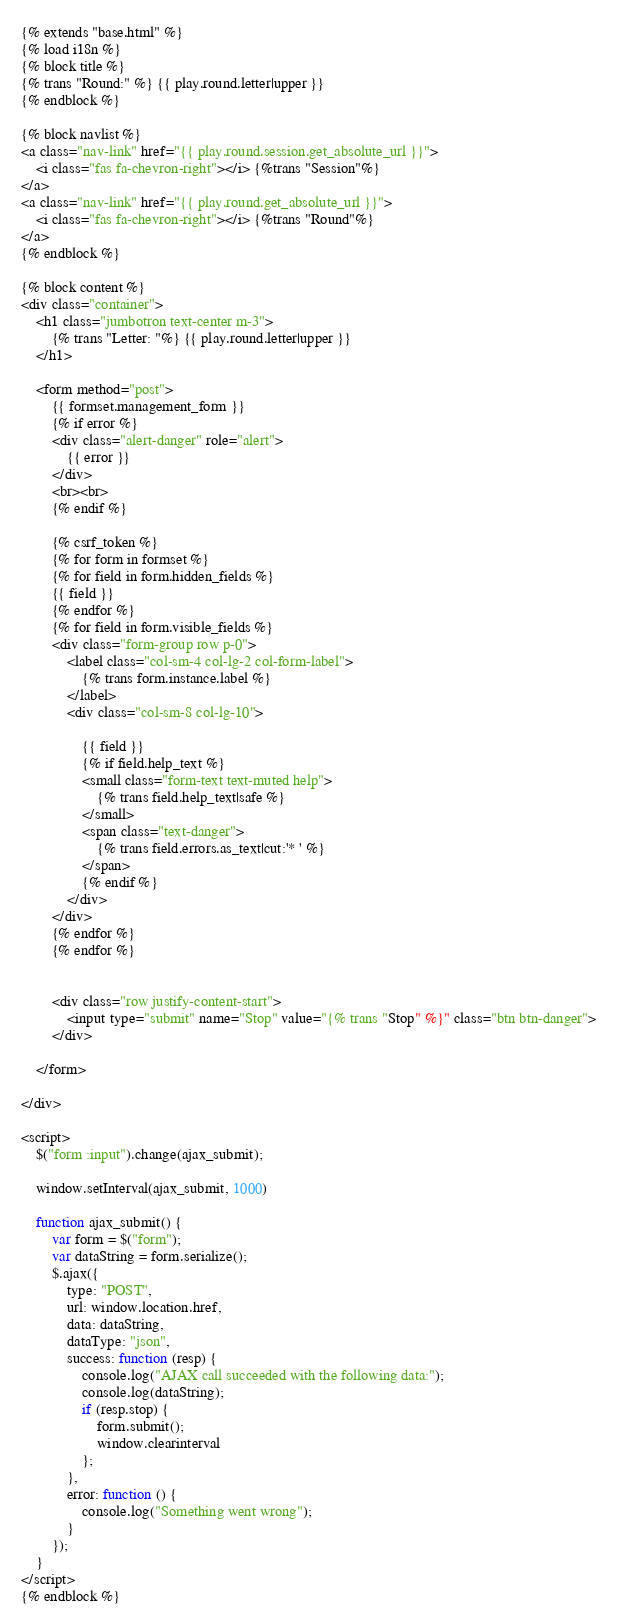Convert code to text. <code><loc_0><loc_0><loc_500><loc_500><_HTML_>{% extends "base.html" %}
{% load i18n %}
{% block title %}
{% trans "Round:" %} {{ play.round.letter|upper }}
{% endblock %}

{% block navlist %}
<a class="nav-link" href="{{ play.round.session.get_absolute_url }}">
    <i class="fas fa-chevron-right"></i> {%trans "Session"%}
</a>
<a class="nav-link" href="{{ play.round.get_absolute_url }}">
    <i class="fas fa-chevron-right"></i> {%trans "Round"%}
</a>
{% endblock %}

{% block content %}
<div class="container">
    <h1 class="jumbotron text-center m-3">
        {% trans "Letter: "%} {{ play.round.letter|upper }}
    </h1>

    <form method="post">
        {{ formset.management_form }}
        {% if error %}
        <div class="alert-danger" role="alert">
            {{ error }}
        </div>
        <br><br>
        {% endif %}

        {% csrf_token %}
        {% for form in formset %}
        {% for field in form.hidden_fields %}
        {{ field }}
        {% endfor %}
        {% for field in form.visible_fields %}
        <div class="form-group row p-0">
            <label class="col-sm-4 col-lg-2 col-form-label">
                {% trans form.instance.label %}
            </label>
            <div class="col-sm-8 col-lg-10">
                
                {{ field }}
                {% if field.help_text %}
                <small class="form-text text-muted help">
                    {% trans field.help_text|safe %}
                </small>
                <span class="text-danger">
                    {% trans field.errors.as_text|cut:'* ' %}
                </span>
                {% endif %}
            </div>
        </div>
        {% endfor %}
        {% endfor %}


        <div class="row justify-content-start">
            <input type="submit" name="Stop" value="{% trans "Stop" %}" class="btn btn-danger">
        </div>

    </form>

</div>

<script>
    $("form :input").change(ajax_submit);

    window.setInterval(ajax_submit, 1000)

    function ajax_submit() {
        var form = $("form");
        var dataString = form.serialize();
        $.ajax({
            type: "POST",
            url: window.location.href,
            data: dataString,
            dataType: "json",
            success: function (resp) {
                console.log("AJAX call succeeded with the following data:");
                console.log(dataString);
                if (resp.stop) {
                    form.submit();
                    window.clearinterval
                };
            },
            error: function () {
                console.log("Something went wrong");
            }
        });
    }
</script>
{% endblock %}</code> 